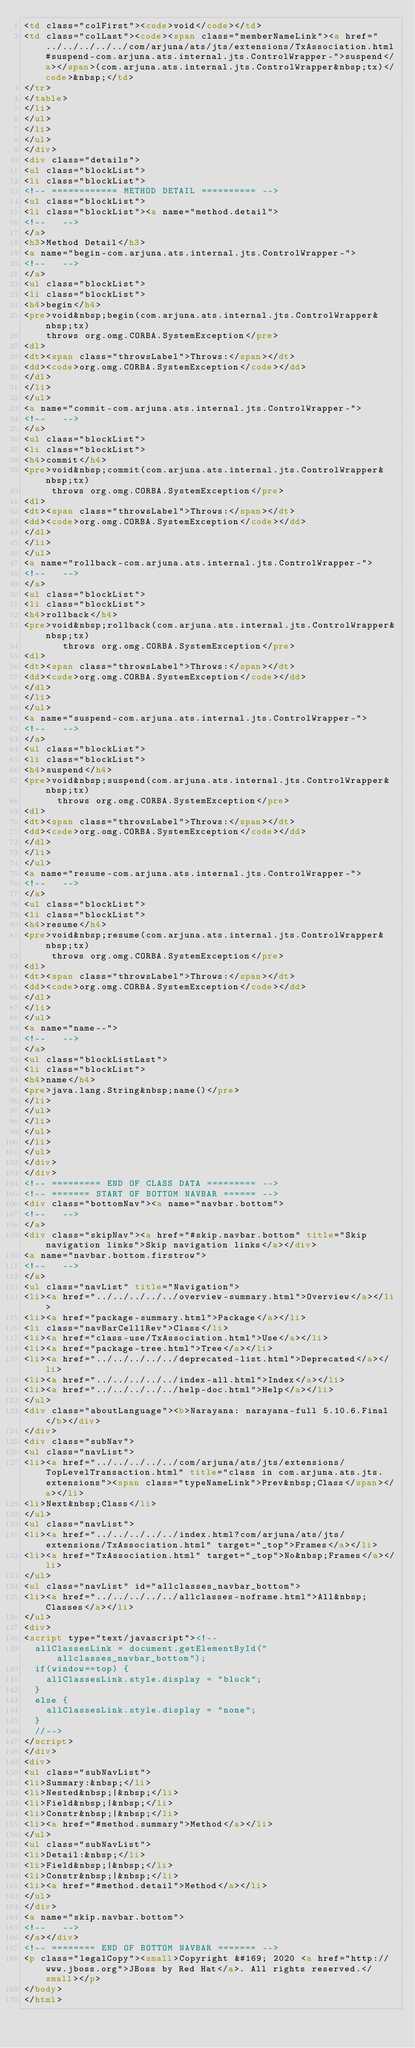<code> <loc_0><loc_0><loc_500><loc_500><_HTML_><td class="colFirst"><code>void</code></td>
<td class="colLast"><code><span class="memberNameLink"><a href="../../../../../com/arjuna/ats/jts/extensions/TxAssociation.html#suspend-com.arjuna.ats.internal.jts.ControlWrapper-">suspend</a></span>(com.arjuna.ats.internal.jts.ControlWrapper&nbsp;tx)</code>&nbsp;</td>
</tr>
</table>
</li>
</ul>
</li>
</ul>
</div>
<div class="details">
<ul class="blockList">
<li class="blockList">
<!-- ============ METHOD DETAIL ========== -->
<ul class="blockList">
<li class="blockList"><a name="method.detail">
<!--   -->
</a>
<h3>Method Detail</h3>
<a name="begin-com.arjuna.ats.internal.jts.ControlWrapper-">
<!--   -->
</a>
<ul class="blockList">
<li class="blockList">
<h4>begin</h4>
<pre>void&nbsp;begin(com.arjuna.ats.internal.jts.ControlWrapper&nbsp;tx)
    throws org.omg.CORBA.SystemException</pre>
<dl>
<dt><span class="throwsLabel">Throws:</span></dt>
<dd><code>org.omg.CORBA.SystemException</code></dd>
</dl>
</li>
</ul>
<a name="commit-com.arjuna.ats.internal.jts.ControlWrapper-">
<!--   -->
</a>
<ul class="blockList">
<li class="blockList">
<h4>commit</h4>
<pre>void&nbsp;commit(com.arjuna.ats.internal.jts.ControlWrapper&nbsp;tx)
     throws org.omg.CORBA.SystemException</pre>
<dl>
<dt><span class="throwsLabel">Throws:</span></dt>
<dd><code>org.omg.CORBA.SystemException</code></dd>
</dl>
</li>
</ul>
<a name="rollback-com.arjuna.ats.internal.jts.ControlWrapper-">
<!--   -->
</a>
<ul class="blockList">
<li class="blockList">
<h4>rollback</h4>
<pre>void&nbsp;rollback(com.arjuna.ats.internal.jts.ControlWrapper&nbsp;tx)
       throws org.omg.CORBA.SystemException</pre>
<dl>
<dt><span class="throwsLabel">Throws:</span></dt>
<dd><code>org.omg.CORBA.SystemException</code></dd>
</dl>
</li>
</ul>
<a name="suspend-com.arjuna.ats.internal.jts.ControlWrapper-">
<!--   -->
</a>
<ul class="blockList">
<li class="blockList">
<h4>suspend</h4>
<pre>void&nbsp;suspend(com.arjuna.ats.internal.jts.ControlWrapper&nbsp;tx)
      throws org.omg.CORBA.SystemException</pre>
<dl>
<dt><span class="throwsLabel">Throws:</span></dt>
<dd><code>org.omg.CORBA.SystemException</code></dd>
</dl>
</li>
</ul>
<a name="resume-com.arjuna.ats.internal.jts.ControlWrapper-">
<!--   -->
</a>
<ul class="blockList">
<li class="blockList">
<h4>resume</h4>
<pre>void&nbsp;resume(com.arjuna.ats.internal.jts.ControlWrapper&nbsp;tx)
     throws org.omg.CORBA.SystemException</pre>
<dl>
<dt><span class="throwsLabel">Throws:</span></dt>
<dd><code>org.omg.CORBA.SystemException</code></dd>
</dl>
</li>
</ul>
<a name="name--">
<!--   -->
</a>
<ul class="blockListLast">
<li class="blockList">
<h4>name</h4>
<pre>java.lang.String&nbsp;name()</pre>
</li>
</ul>
</li>
</ul>
</li>
</ul>
</div>
</div>
<!-- ========= END OF CLASS DATA ========= -->
<!-- ======= START OF BOTTOM NAVBAR ====== -->
<div class="bottomNav"><a name="navbar.bottom">
<!--   -->
</a>
<div class="skipNav"><a href="#skip.navbar.bottom" title="Skip navigation links">Skip navigation links</a></div>
<a name="navbar.bottom.firstrow">
<!--   -->
</a>
<ul class="navList" title="Navigation">
<li><a href="../../../../../overview-summary.html">Overview</a></li>
<li><a href="package-summary.html">Package</a></li>
<li class="navBarCell1Rev">Class</li>
<li><a href="class-use/TxAssociation.html">Use</a></li>
<li><a href="package-tree.html">Tree</a></li>
<li><a href="../../../../../deprecated-list.html">Deprecated</a></li>
<li><a href="../../../../../index-all.html">Index</a></li>
<li><a href="../../../../../help-doc.html">Help</a></li>
</ul>
<div class="aboutLanguage"><b>Narayana: narayana-full 5.10.6.Final</b></div>
</div>
<div class="subNav">
<ul class="navList">
<li><a href="../../../../../com/arjuna/ats/jts/extensions/TopLevelTransaction.html" title="class in com.arjuna.ats.jts.extensions"><span class="typeNameLink">Prev&nbsp;Class</span></a></li>
<li>Next&nbsp;Class</li>
</ul>
<ul class="navList">
<li><a href="../../../../../index.html?com/arjuna/ats/jts/extensions/TxAssociation.html" target="_top">Frames</a></li>
<li><a href="TxAssociation.html" target="_top">No&nbsp;Frames</a></li>
</ul>
<ul class="navList" id="allclasses_navbar_bottom">
<li><a href="../../../../../allclasses-noframe.html">All&nbsp;Classes</a></li>
</ul>
<div>
<script type="text/javascript"><!--
  allClassesLink = document.getElementById("allclasses_navbar_bottom");
  if(window==top) {
    allClassesLink.style.display = "block";
  }
  else {
    allClassesLink.style.display = "none";
  }
  //-->
</script>
</div>
<div>
<ul class="subNavList">
<li>Summary:&nbsp;</li>
<li>Nested&nbsp;|&nbsp;</li>
<li>Field&nbsp;|&nbsp;</li>
<li>Constr&nbsp;|&nbsp;</li>
<li><a href="#method.summary">Method</a></li>
</ul>
<ul class="subNavList">
<li>Detail:&nbsp;</li>
<li>Field&nbsp;|&nbsp;</li>
<li>Constr&nbsp;|&nbsp;</li>
<li><a href="#method.detail">Method</a></li>
</ul>
</div>
<a name="skip.navbar.bottom">
<!--   -->
</a></div>
<!-- ======== END OF BOTTOM NAVBAR ======= -->
<p class="legalCopy"><small>Copyright &#169; 2020 <a href="http://www.jboss.org">JBoss by Red Hat</a>. All rights reserved.</small></p>
</body>
</html>
</code> 